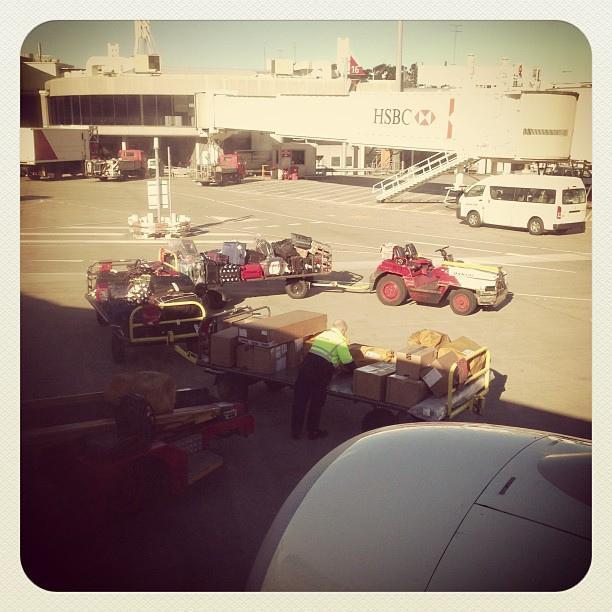Verify the accuracy of this image caption: "The airplane is touching the person.".
Answer yes or no. No. 